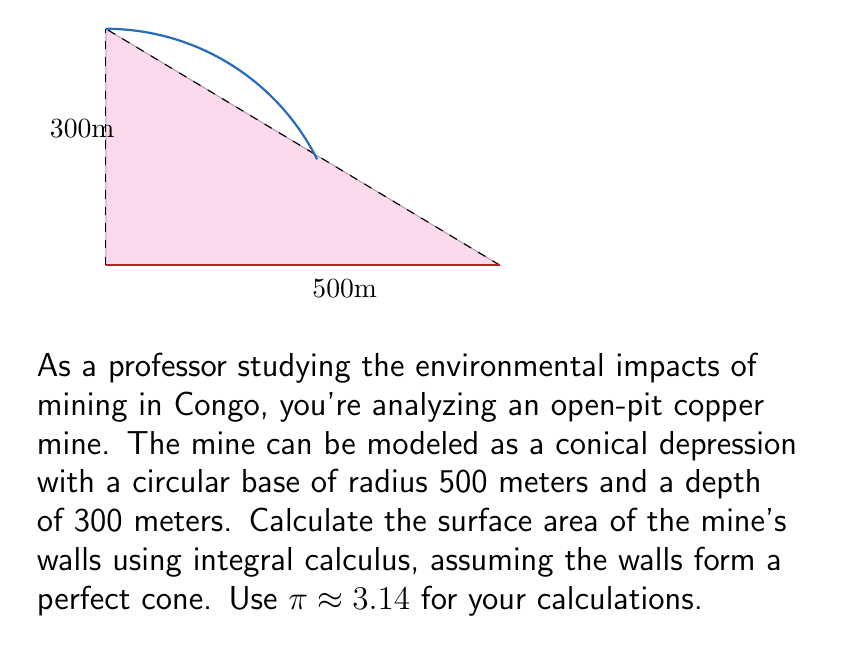Give your solution to this math problem. Let's approach this step-by-step:

1) In a conical pit, we can use the formula for the lateral surface area of a cone:
   
   $$A = \pi r \sqrt{r^2 + h^2}$$

   where $r$ is the radius of the base and $h$ is the height of the cone.

2) However, to demonstrate the use of integral calculus, we'll derive this formula.

3) Let's set up a coordinate system where the apex of the cone is at (0,0,300) and the base is in the xy-plane.

4) The equation of the cone's surface is:

   $$z = 300 - \frac{300}{500}\sqrt{x^2 + y^2}$$

5) To find the surface area, we need to integrate the surface element $dS$ over the entire surface:

   $$A = \int\int dS$$

6) For a surface $z = f(x,y)$, the surface element is given by:

   $$dS = \sqrt{1 + (\frac{\partial z}{\partial x})^2 + (\frac{\partial z}{\partial y})^2} dxdy$$

7) Calculate the partial derivatives:

   $$\frac{\partial z}{\partial x} = -\frac{300}{500} \cdot \frac{x}{\sqrt{x^2 + y^2}}$$
   $$\frac{\partial z}{\partial y} = -\frac{300}{500} \cdot \frac{y}{\sqrt{x^2 + y^2}}$$

8) Substitute these into the surface element formula:

   $$dS = \sqrt{1 + (\frac{300}{500})^2 \cdot \frac{x^2 + y^2}{x^2 + y^2}} dxdy = \sqrt{1 + (\frac{300}{500})^2} dxdy$$

9) The surface area integral becomes:

   $$A = \int_0^{2\pi} \int_0^{500} \sqrt{1 + (\frac{300}{500})^2} r dr d\theta$$

10) Evaluate the integral:

    $$A = 2\pi \cdot 500 \cdot \frac{1}{2} \sqrt{1 + (\frac{300}{500})^2}$$

11) Simplify:

    $$A = \pi \cdot 500 \sqrt{500^2 + 300^2} \approx 942,477.8 \text{ m}^2$$
Answer: 942,478 m² 